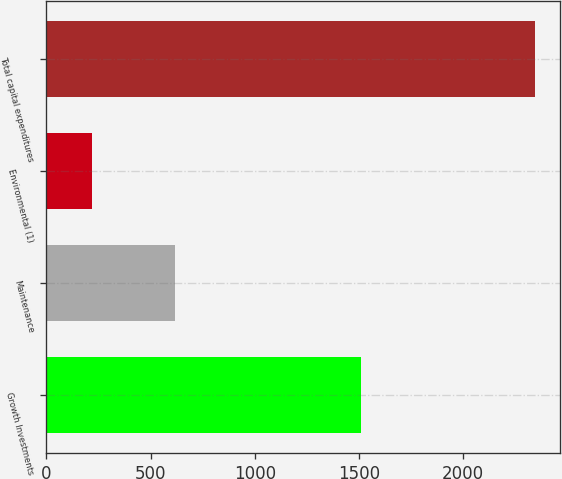<chart> <loc_0><loc_0><loc_500><loc_500><bar_chart><fcel>Growth Investments<fcel>Maintenance<fcel>Environmental (1)<fcel>Total capital expenditures<nl><fcel>1510<fcel>617<fcel>218<fcel>2345<nl></chart> 